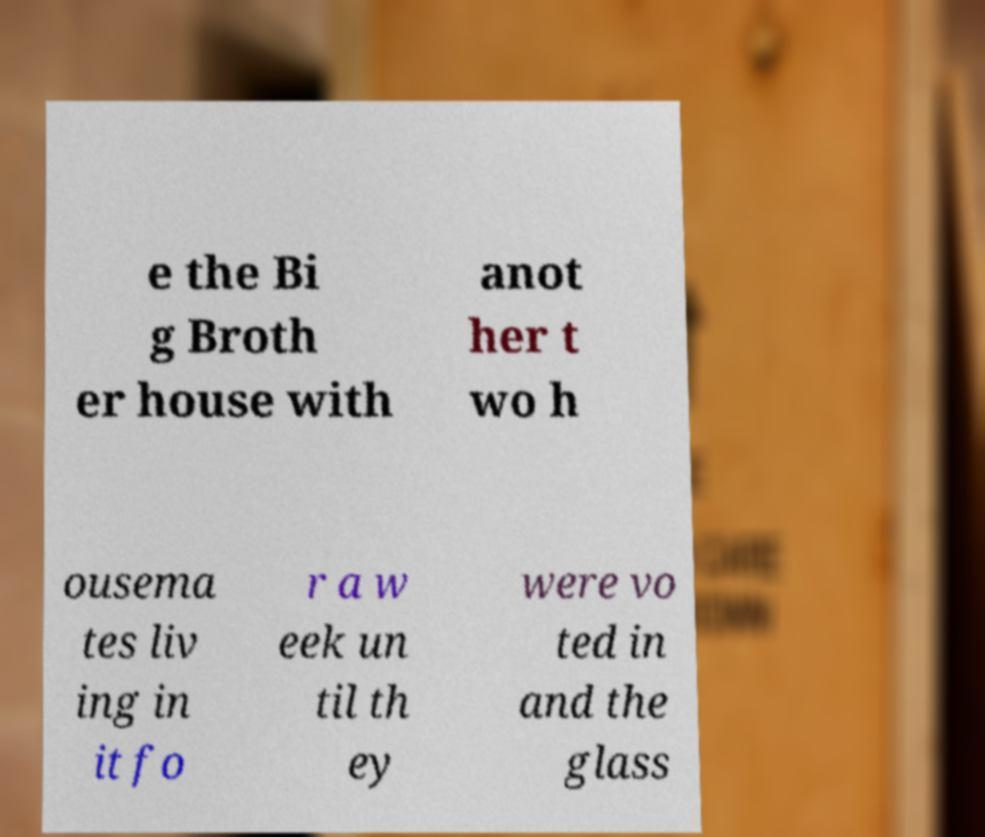There's text embedded in this image that I need extracted. Can you transcribe it verbatim? e the Bi g Broth er house with anot her t wo h ousema tes liv ing in it fo r a w eek un til th ey were vo ted in and the glass 